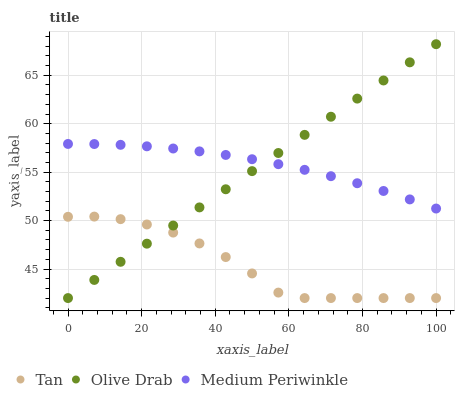Does Tan have the minimum area under the curve?
Answer yes or no. Yes. Does Medium Periwinkle have the maximum area under the curve?
Answer yes or no. Yes. Does Olive Drab have the minimum area under the curve?
Answer yes or no. No. Does Olive Drab have the maximum area under the curve?
Answer yes or no. No. Is Olive Drab the smoothest?
Answer yes or no. Yes. Is Tan the roughest?
Answer yes or no. Yes. Is Medium Periwinkle the smoothest?
Answer yes or no. No. Is Medium Periwinkle the roughest?
Answer yes or no. No. Does Tan have the lowest value?
Answer yes or no. Yes. Does Medium Periwinkle have the lowest value?
Answer yes or no. No. Does Olive Drab have the highest value?
Answer yes or no. Yes. Does Medium Periwinkle have the highest value?
Answer yes or no. No. Is Tan less than Medium Periwinkle?
Answer yes or no. Yes. Is Medium Periwinkle greater than Tan?
Answer yes or no. Yes. Does Medium Periwinkle intersect Olive Drab?
Answer yes or no. Yes. Is Medium Periwinkle less than Olive Drab?
Answer yes or no. No. Is Medium Periwinkle greater than Olive Drab?
Answer yes or no. No. Does Tan intersect Medium Periwinkle?
Answer yes or no. No. 